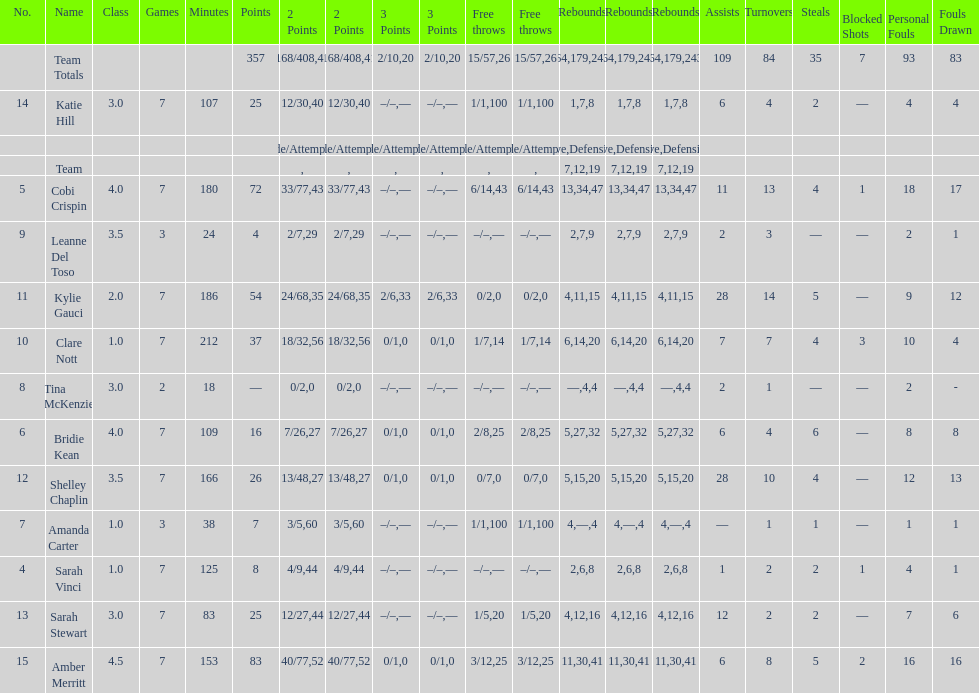Number of 3 points attempted 10. 